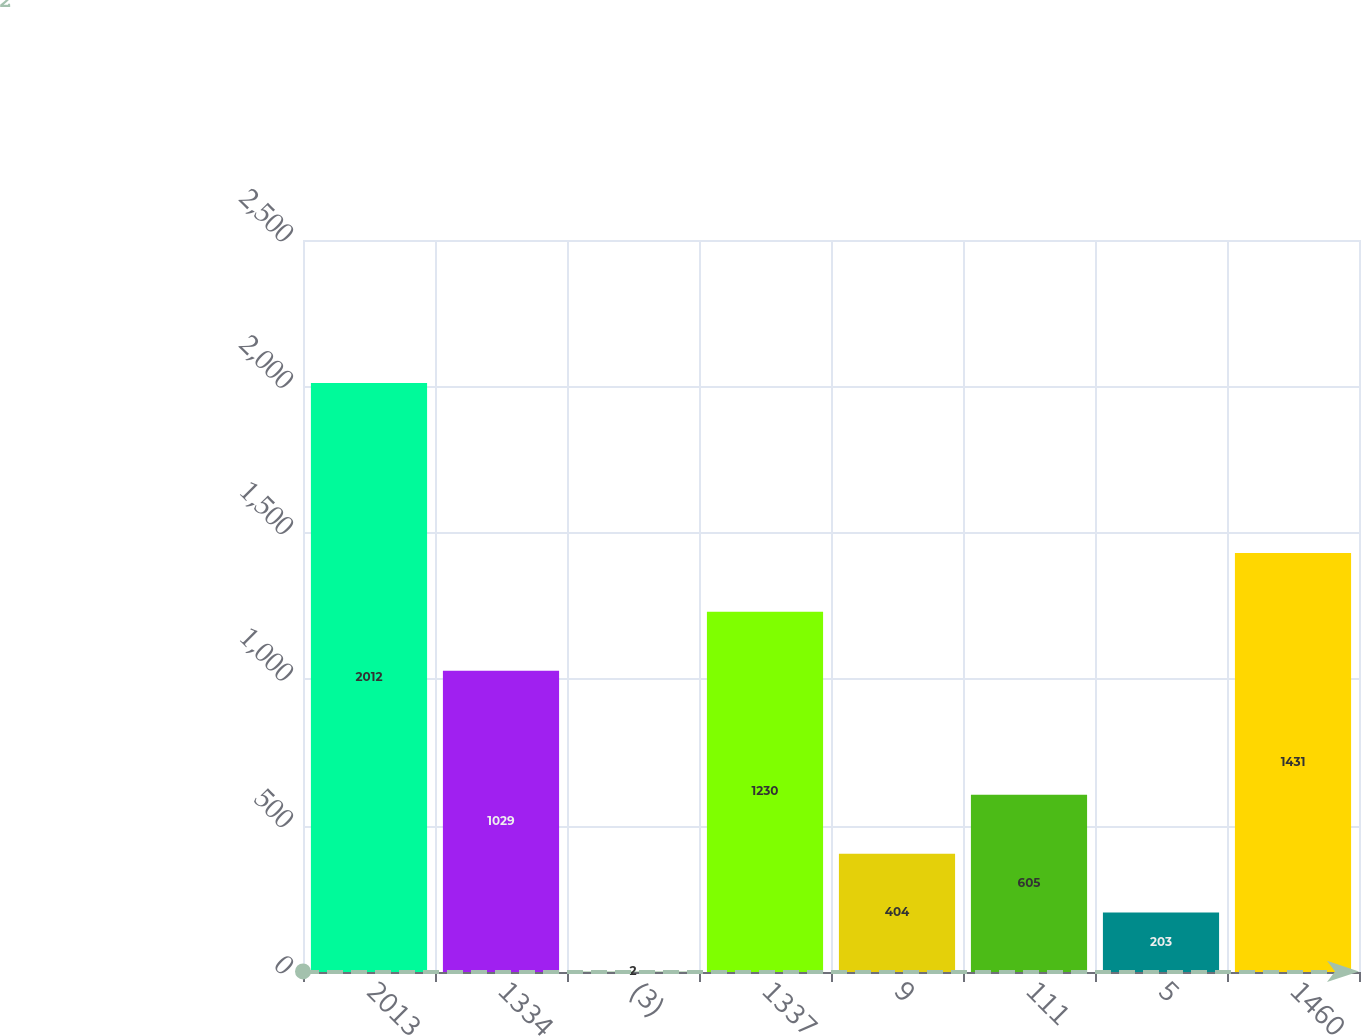<chart> <loc_0><loc_0><loc_500><loc_500><bar_chart><fcel>2013<fcel>1334<fcel>(3)<fcel>1337<fcel>9<fcel>111<fcel>5<fcel>1460<nl><fcel>2012<fcel>1029<fcel>2<fcel>1230<fcel>404<fcel>605<fcel>203<fcel>1431<nl></chart> 